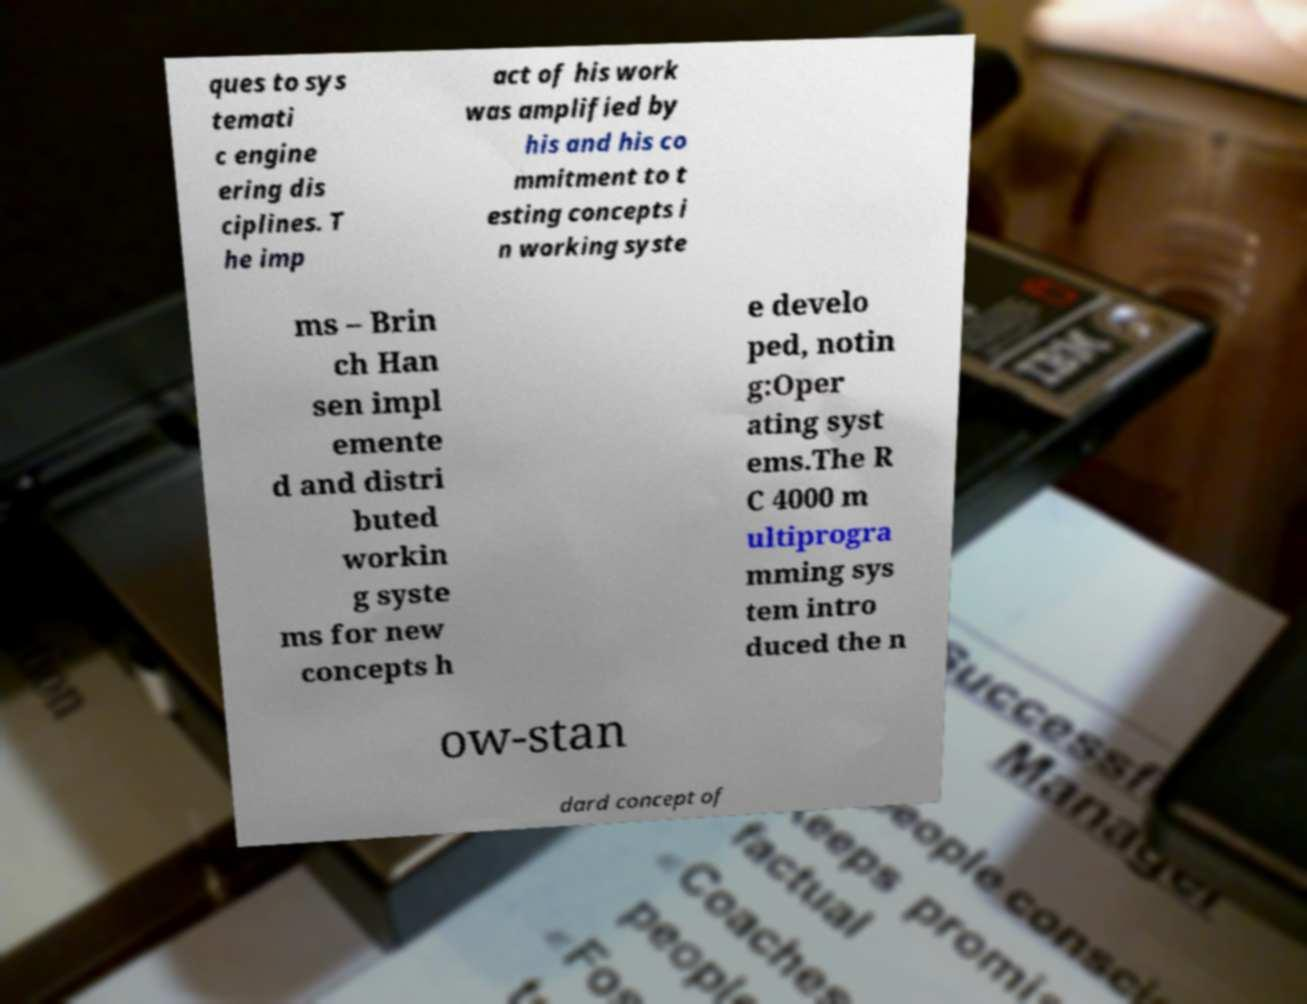Please identify and transcribe the text found in this image. ques to sys temati c engine ering dis ciplines. T he imp act of his work was amplified by his and his co mmitment to t esting concepts i n working syste ms – Brin ch Han sen impl emente d and distri buted workin g syste ms for new concepts h e develo ped, notin g:Oper ating syst ems.The R C 4000 m ultiprogra mming sys tem intro duced the n ow-stan dard concept of 